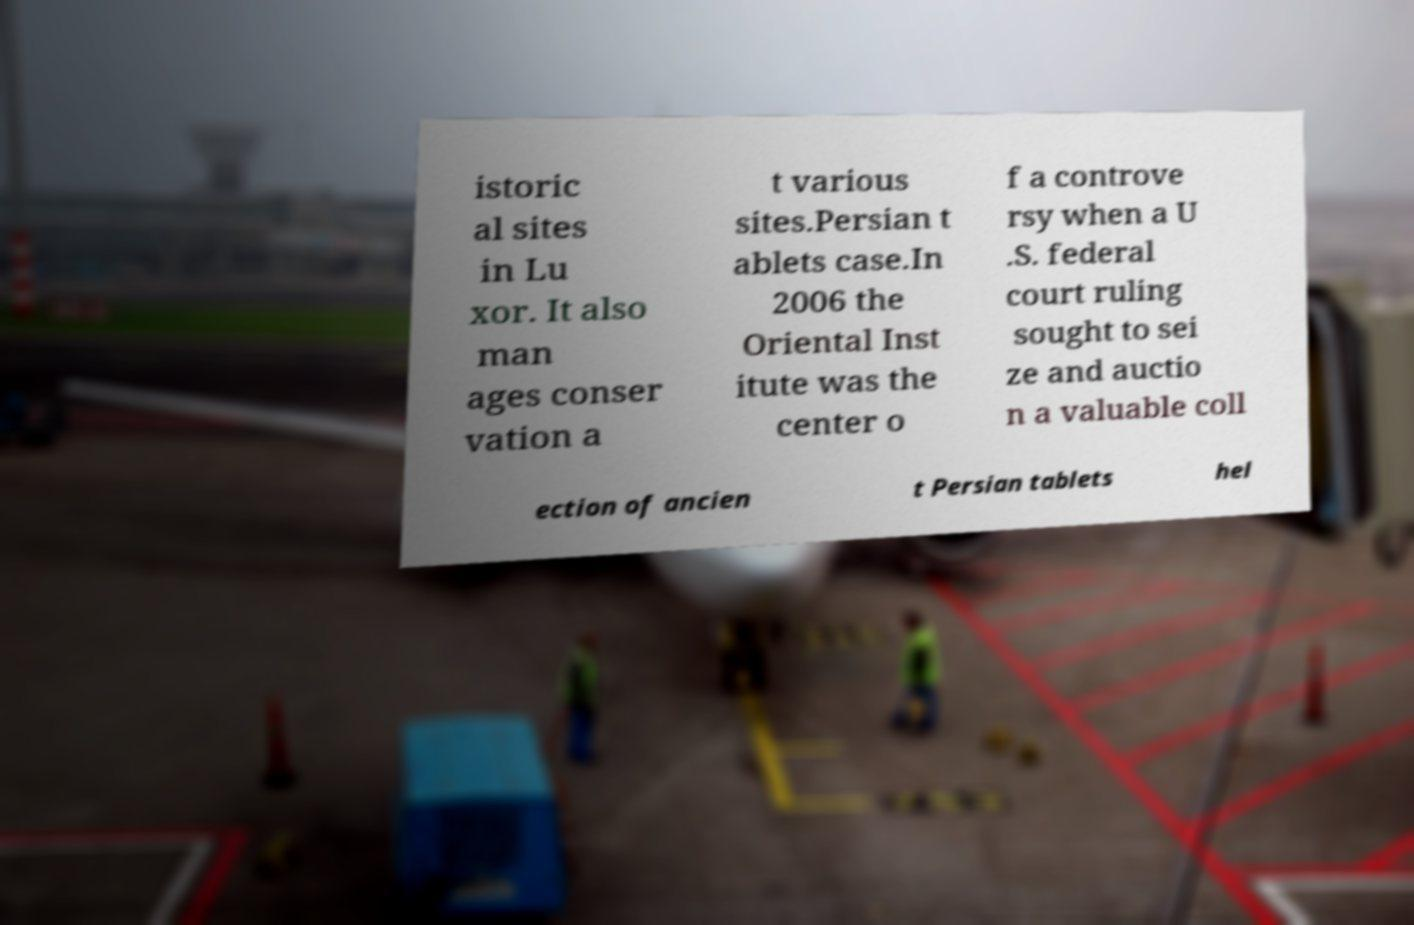What messages or text are displayed in this image? I need them in a readable, typed format. istoric al sites in Lu xor. It also man ages conser vation a t various sites.Persian t ablets case.In 2006 the Oriental Inst itute was the center o f a controve rsy when a U .S. federal court ruling sought to sei ze and auctio n a valuable coll ection of ancien t Persian tablets hel 